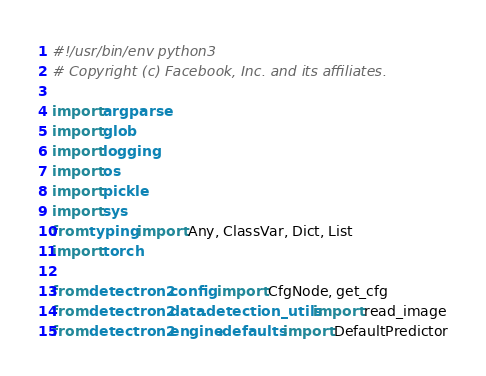<code> <loc_0><loc_0><loc_500><loc_500><_Python_>#!/usr/bin/env python3
# Copyright (c) Facebook, Inc. and its affiliates.

import argparse
import glob
import logging
import os
import pickle
import sys
from typing import Any, ClassVar, Dict, List
import torch

from detectron2.config import CfgNode, get_cfg
from detectron2.data.detection_utils import read_image
from detectron2.engine.defaults import DefaultPredictor</code> 